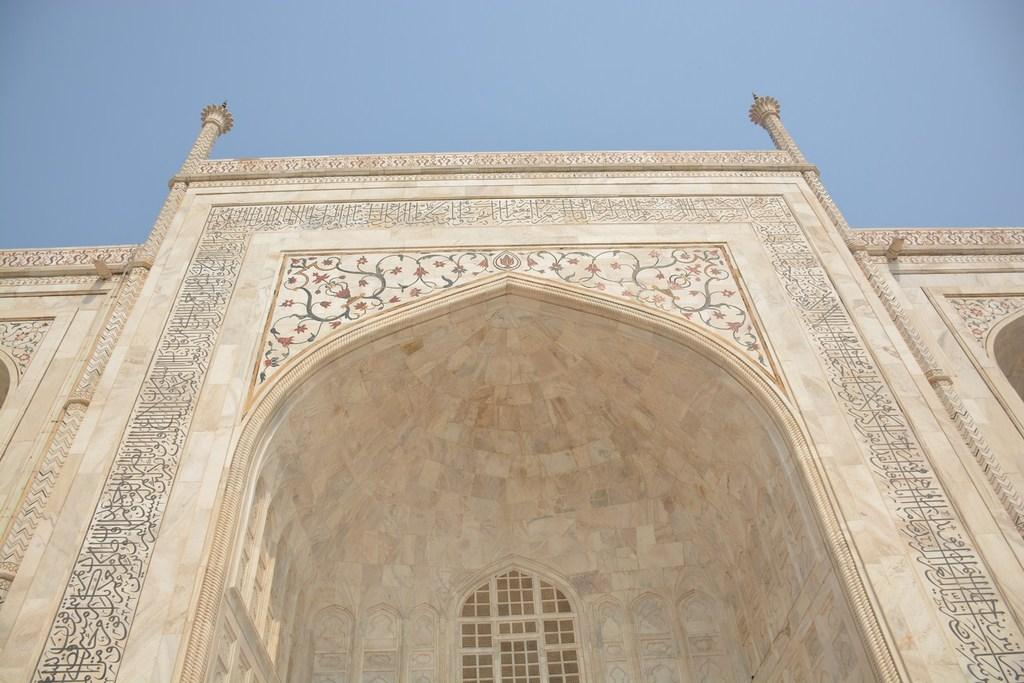What can be seen in the background of the image? The sky is visible in the background of the image. What architectural feature is present in the image? There is a grille in the image. How are the walls in the image decorated? The walls in the image have a designed pattern. What structural elements can be seen in the image? There are pillars in the image. What type of toothpaste is being used to clean the pillars in the image? There is no toothpaste present in the image, and the pillars are not being cleaned. 